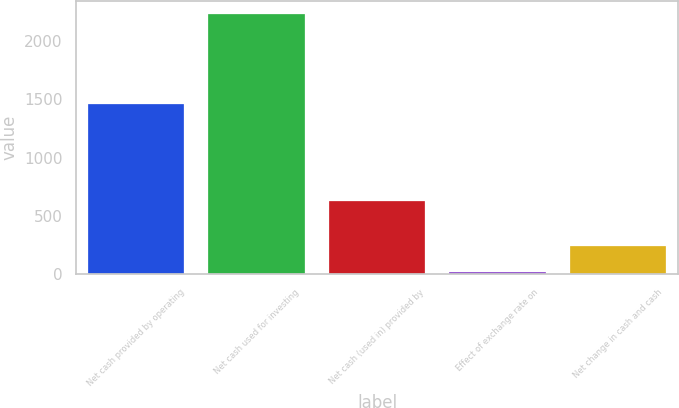Convert chart to OTSL. <chart><loc_0><loc_0><loc_500><loc_500><bar_chart><fcel>Net cash provided by operating<fcel>Net cash used for investing<fcel>Net cash (used in) provided by<fcel>Effect of exchange rate on<fcel>Net change in cash and cash<nl><fcel>1459.4<fcel>2228.7<fcel>631.9<fcel>20.5<fcel>241.32<nl></chart> 